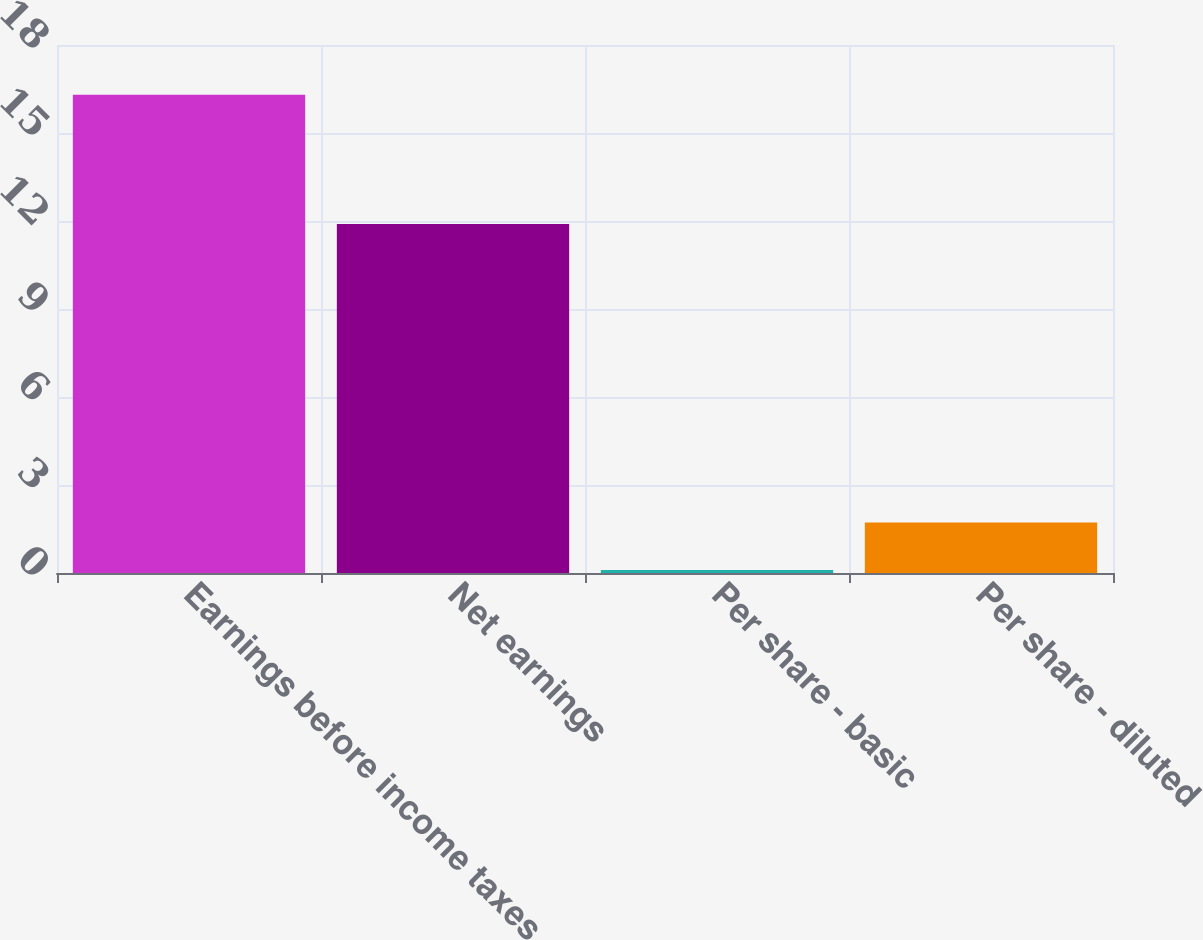Convert chart to OTSL. <chart><loc_0><loc_0><loc_500><loc_500><bar_chart><fcel>Earnings before income taxes<fcel>Net earnings<fcel>Per share - basic<fcel>Per share - diluted<nl><fcel>16.3<fcel>11.9<fcel>0.1<fcel>1.72<nl></chart> 